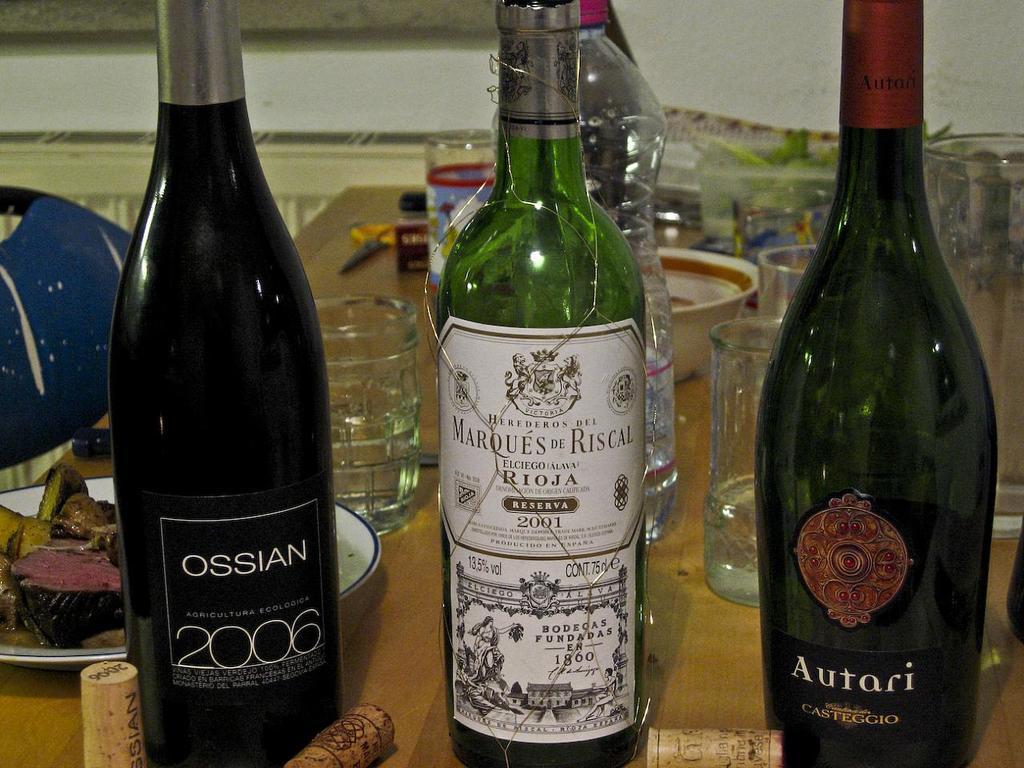In what year was the left bottle made?
Ensure brevity in your answer.  2006. 